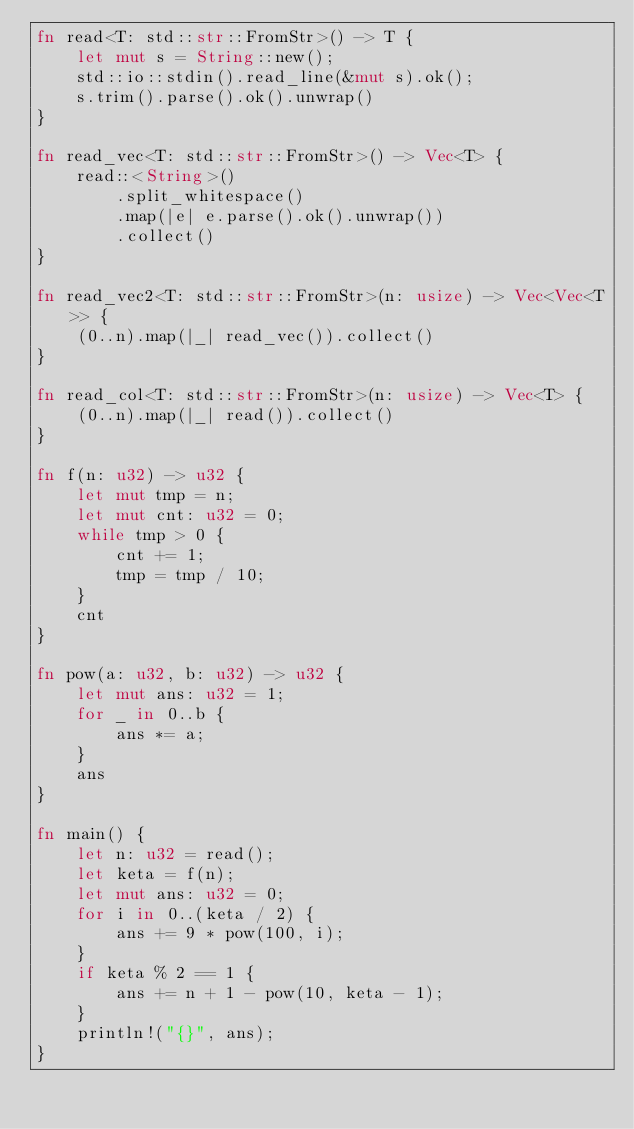Convert code to text. <code><loc_0><loc_0><loc_500><loc_500><_Rust_>fn read<T: std::str::FromStr>() -> T {
    let mut s = String::new();
    std::io::stdin().read_line(&mut s).ok();
    s.trim().parse().ok().unwrap()
}

fn read_vec<T: std::str::FromStr>() -> Vec<T> {
    read::<String>()
        .split_whitespace()
        .map(|e| e.parse().ok().unwrap())
        .collect()
}

fn read_vec2<T: std::str::FromStr>(n: usize) -> Vec<Vec<T>> {
    (0..n).map(|_| read_vec()).collect()
}

fn read_col<T: std::str::FromStr>(n: usize) -> Vec<T> {
    (0..n).map(|_| read()).collect()
}

fn f(n: u32) -> u32 {
    let mut tmp = n;
    let mut cnt: u32 = 0;
    while tmp > 0 {
        cnt += 1;
        tmp = tmp / 10;
    }
    cnt
}

fn pow(a: u32, b: u32) -> u32 {
    let mut ans: u32 = 1;
    for _ in 0..b {
        ans *= a;
    }
    ans
}

fn main() {
    let n: u32 = read();
    let keta = f(n);
    let mut ans: u32 = 0;
    for i in 0..(keta / 2) {
        ans += 9 * pow(100, i);
    }
    if keta % 2 == 1 {
        ans += n + 1 - pow(10, keta - 1);
    }
    println!("{}", ans);
}
</code> 